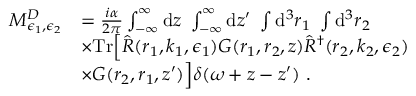Convert formula to latex. <formula><loc_0><loc_0><loc_500><loc_500>\begin{array} { r l } { M _ { \epsilon _ { 1 } , \epsilon _ { 2 } } ^ { D } } & { = \frac { i \alpha } { 2 \pi } \int _ { - \infty } ^ { \infty } d z \int _ { - \infty } ^ { \infty } d z ^ { \prime } \int d ^ { 3 } r _ { 1 } \int d ^ { 3 } r _ { 2 } } \\ & { \times T r \left [ \hat { R } ( r _ { 1 } , k _ { 1 } , \epsilon _ { 1 } ) G ( r _ { 1 } , r _ { 2 } , z ) \hat { R } ^ { \dagger } ( r _ { 2 } , k _ { 2 } , \epsilon _ { 2 } ) } \\ & { \times G ( r _ { 2 } , r _ { 1 } , z ^ { \prime } ) \right ] \delta ( \omega + z - z ^ { \prime } ) . } \end{array}</formula> 